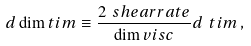<formula> <loc_0><loc_0><loc_500><loc_500>d \dim t i m \equiv \frac { 2 \ s h e a r r a t e } { \dim v i s c } d \ t i m \, ,</formula> 